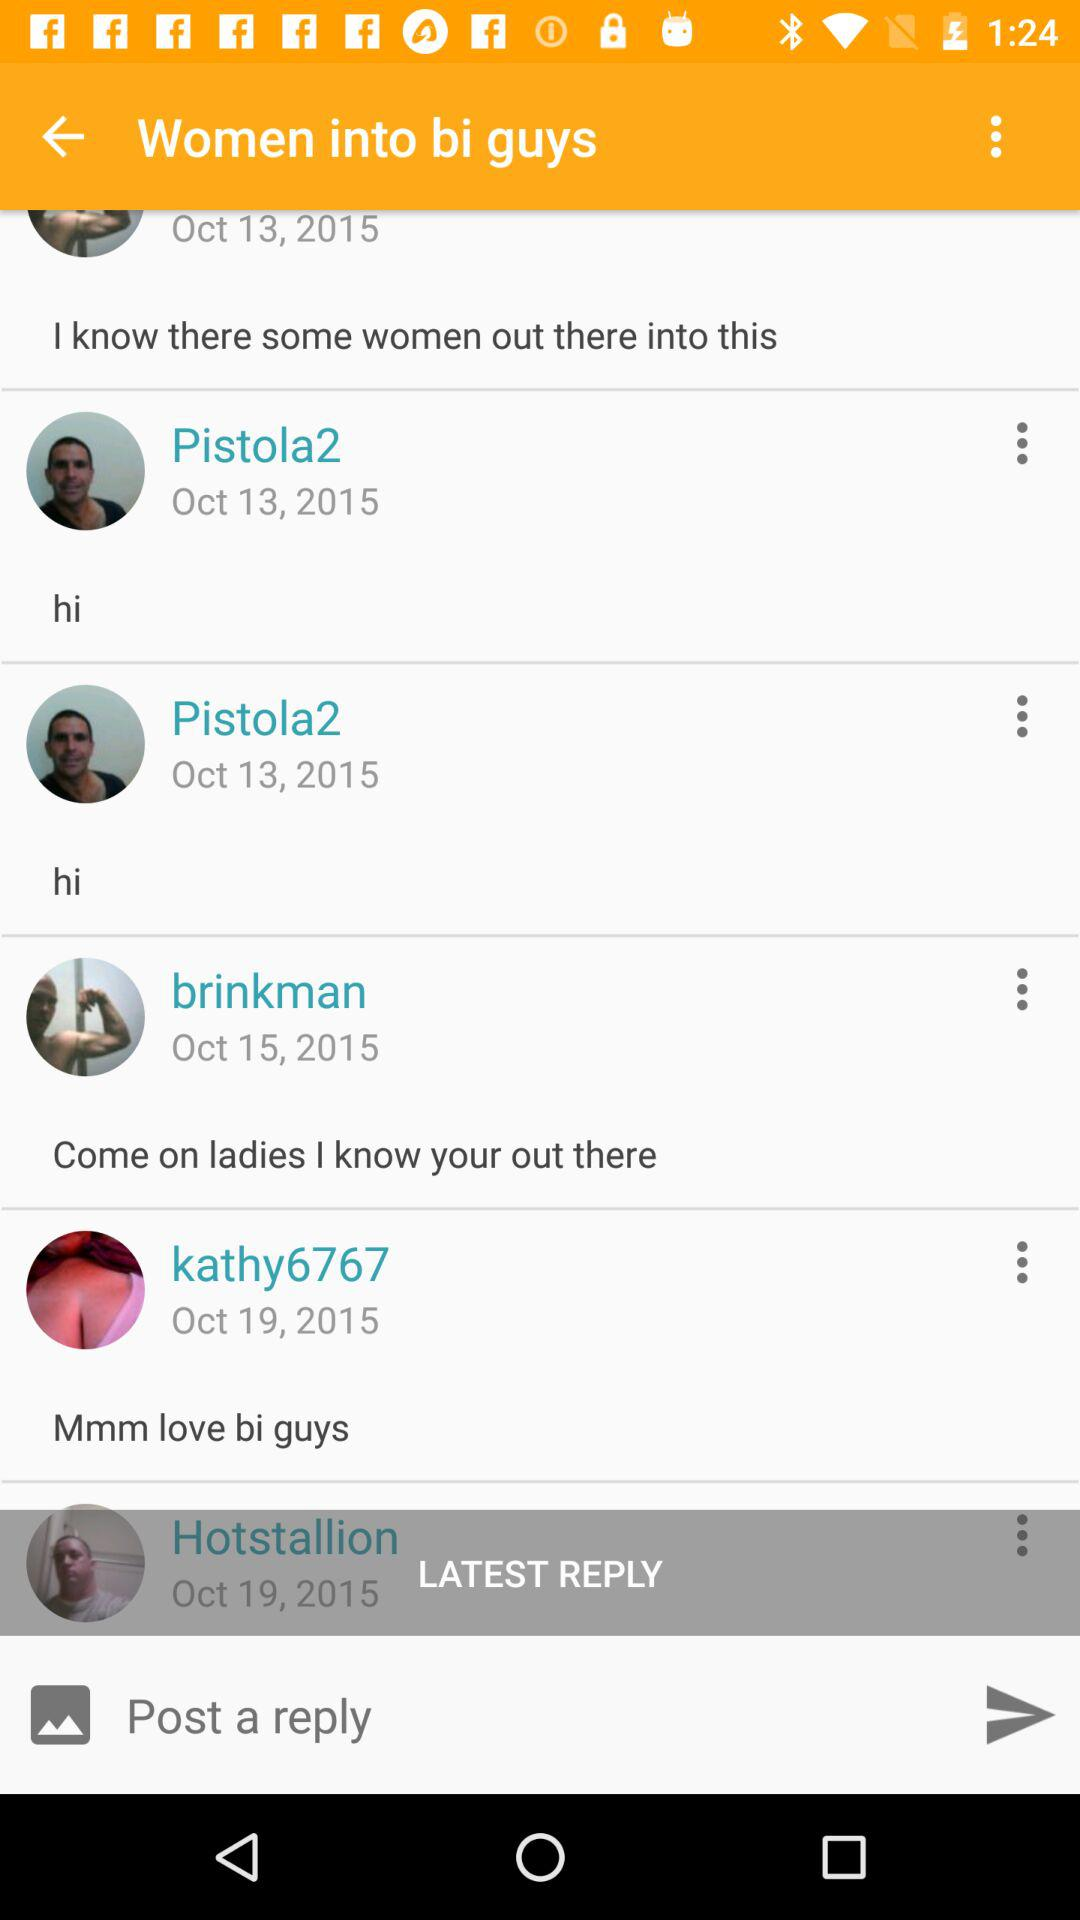What date did "Pistola2" post the comment? "Pistola2" posted the comment on October 13, 2015. 